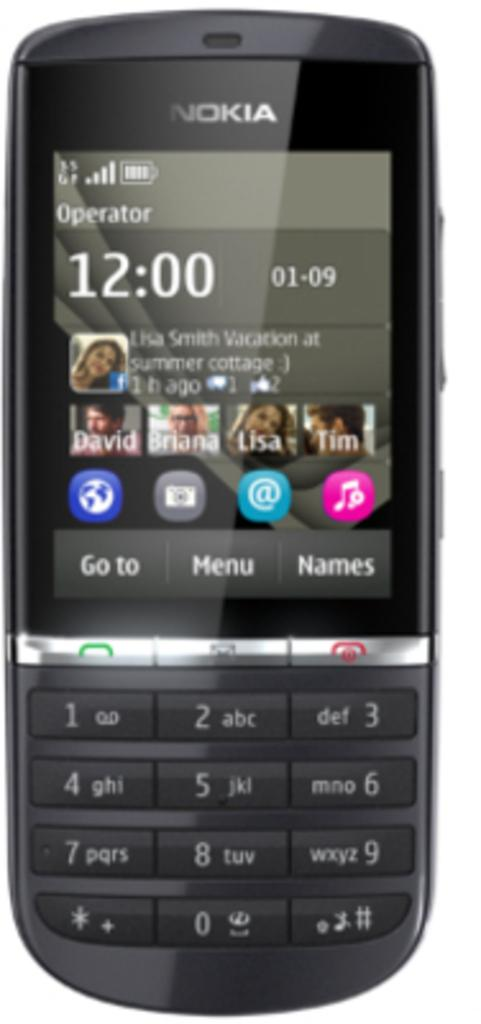<image>
Write a terse but informative summary of the picture. A Nokia phone says the time is 12:09 on January 9th. 